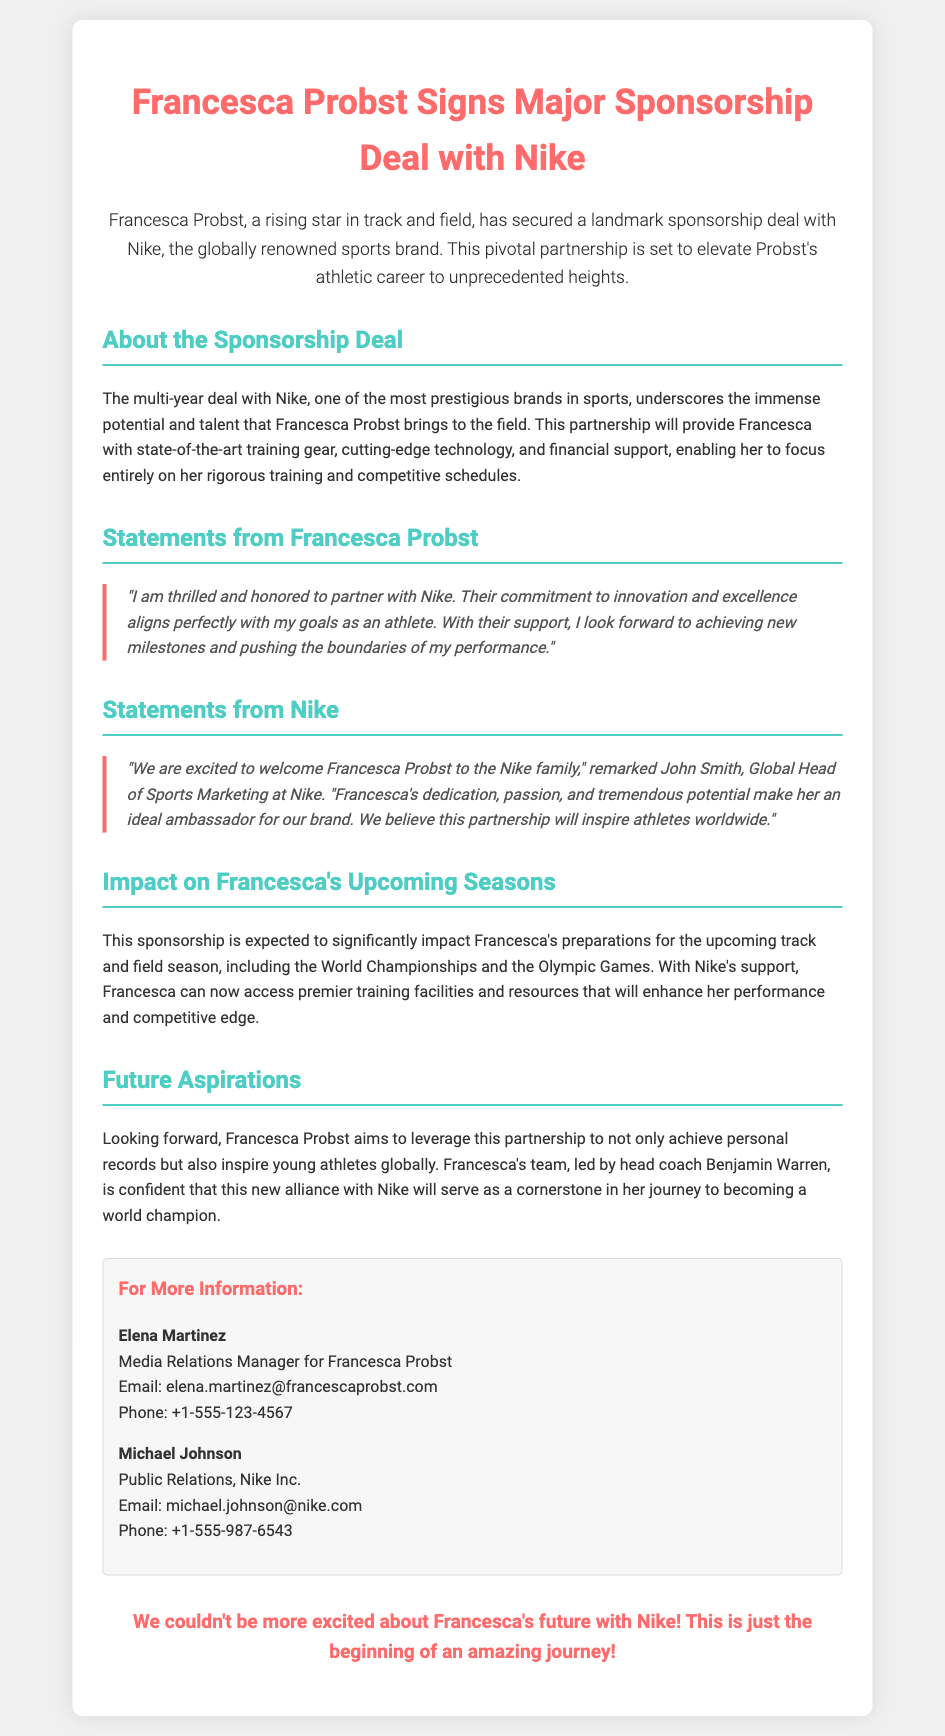What brand has Francesca Probst signed a sponsorship deal with? The document explicitly states that Francesca Probst has signed a sponsorship deal with Nike, a leading sports brand.
Answer: Nike What is the nature of the sponsorship deal? The document indicates that the deal is a multi-year sponsorship, which highlights its long-term commitment.
Answer: Multi-year Who is Francesca Probst's head coach? The document mentions that Benjamin Warren is identified as Francesca's head coach in her team.
Answer: Benjamin Warren What is Francesca Probst’s goal with Nike's support? The document reveals that Francesca aims for achieving new milestones in her athletic performance with Nike's backing.
Answer: New milestones What facilities will Francesca have access to due to the sponsorship? The document notes that Francesca will have access to premier training facilities, enhancing her preparation for competitions.
Answer: Premier training facilities Who made a statement on behalf of Nike? The document quotes John Smith as the Global Head of Sports Marketing at Nike, who provided a statement regarding the partnership.
Answer: John Smith What upcoming competitions are mentioned that Francesca is preparing for? The document highlights that Francesca is preparing for the World Championships and the Olympic Games in the near future.
Answer: World Championships and the Olympic Games What type of impact is the sponsorship expected to have on Francesca? The document states that the sponsorship is anticipated to significantly impact Francesca's preparations and competitive edge.
Answer: Significantly impact What role does financial support play in the sponsorship? The document mentions that financial support is a key component of the sponsorship, enabling Francesca to focus on her training.
Answer: Focus on her training 